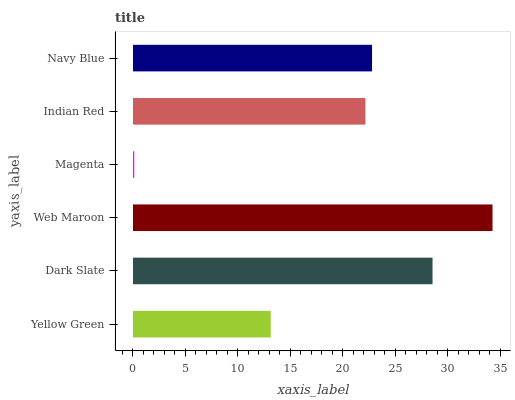Is Magenta the minimum?
Answer yes or no. Yes. Is Web Maroon the maximum?
Answer yes or no. Yes. Is Dark Slate the minimum?
Answer yes or no. No. Is Dark Slate the maximum?
Answer yes or no. No. Is Dark Slate greater than Yellow Green?
Answer yes or no. Yes. Is Yellow Green less than Dark Slate?
Answer yes or no. Yes. Is Yellow Green greater than Dark Slate?
Answer yes or no. No. Is Dark Slate less than Yellow Green?
Answer yes or no. No. Is Navy Blue the high median?
Answer yes or no. Yes. Is Indian Red the low median?
Answer yes or no. Yes. Is Web Maroon the high median?
Answer yes or no. No. Is Web Maroon the low median?
Answer yes or no. No. 